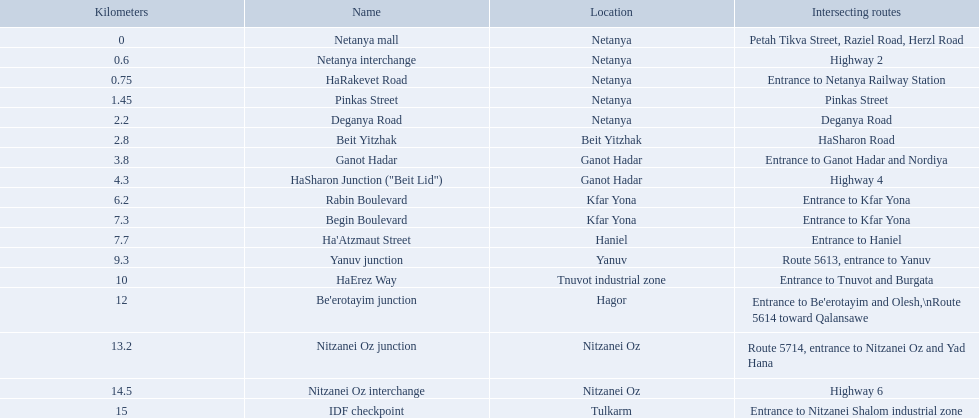What are all of the different portions? Netanya mall, Netanya interchange, HaRakevet Road, Pinkas Street, Deganya Road, Beit Yitzhak, Ganot Hadar, HaSharon Junction ("Beit Lid"), Rabin Boulevard, Begin Boulevard, Ha'Atzmaut Street, Yanuv junction, HaErez Way, Be'erotayim junction, Nitzanei Oz junction, Nitzanei Oz interchange, IDF checkpoint. What is the intersecting route for rabin boulevard? Entrance to Kfar Yona. What portion also has an intersecting route of entrance to kfar yona? Begin Boulevard. What is the converging route of rabin boulevard? Entrance to Kfar Yona. Which segment has this converging route? Begin Boulevard. What are all the designations? Netanya mall, Netanya interchange, HaRakevet Road, Pinkas Street, Deganya Road, Beit Yitzhak, Ganot Hadar, HaSharon Junction ("Beit Lid"), Rabin Boulevard, Begin Boulevard, Ha'Atzmaut Street, Yanuv junction, HaErez Way, Be'erotayim junction, Nitzanei Oz junction, Nitzanei Oz interchange, IDF checkpoint. Where do they meet? Petah Tikva Street, Raziel Road, Herzl Road, Highway 2, Entrance to Netanya Railway Station, Pinkas Street, Deganya Road, HaSharon Road, Entrance to Ganot Hadar and Nordiya, Highway 4, Entrance to Kfar Yona, Entrance to Kfar Yona, Entrance to Haniel, Route 5613, entrance to Yanuv, Entrance to Tnuvot and Burgata, Entrance to Be'erotayim and Olesh,\nRoute 5614 toward Qalansawe, Route 5714, entrance to Nitzanei Oz and Yad Hana, Highway 6, Entrance to Nitzanei Shalom industrial zone. And which one intersects with rabin boulevard? Begin Boulevard. What are the distinct sections? Netanya mall, Netanya interchange, HaRakevet Road, Pinkas Street, Deganya Road, Beit Yitzhak, Ganot Hadar, HaSharon Junction ("Beit Lid"), Rabin Boulevard, Begin Boulevard, Ha'Atzmaut Street, Yanuv junction, HaErez Way, Be'erotayim junction, Nitzanei Oz junction, Nitzanei Oz interchange, IDF checkpoint. What is the converging route on rabin boulevard? Entrance to Kfar Yona. What section also features a crossing path for access to kfar yona? Begin Boulevard. What are the separate parts? Netanya mall, Netanya interchange, HaRakevet Road, Pinkas Street, Deganya Road, Beit Yitzhak, Ganot Hadar, HaSharon Junction ("Beit Lid"), Rabin Boulevard, Begin Boulevard, Ha'Atzmaut Street, Yanuv junction, HaErez Way, Be'erotayim junction, Nitzanei Oz junction, Nitzanei Oz interchange, IDF checkpoint. What is the junction point for rabin boulevard? Entrance to Kfar Yona. Which part also contains an intersection for the entrance to kfar yona? Begin Boulevard. What are the various titles? Netanya mall, Netanya interchange, HaRakevet Road, Pinkas Street, Deganya Road, Beit Yitzhak, Ganot Hadar, HaSharon Junction ("Beit Lid"), Rabin Boulevard, Begin Boulevard, Ha'Atzmaut Street, Yanuv junction, HaErez Way, Be'erotayim junction, Nitzanei Oz junction, Nitzanei Oz interchange, IDF checkpoint. Where do they coincide? Petah Tikva Street, Raziel Road, Herzl Road, Highway 2, Entrance to Netanya Railway Station, Pinkas Street, Deganya Road, HaSharon Road, Entrance to Ganot Hadar and Nordiya, Highway 4, Entrance to Kfar Yona, Entrance to Kfar Yona, Entrance to Haniel, Route 5613, entrance to Yanuv, Entrance to Tnuvot and Burgata, Entrance to Be'erotayim and Olesh,\nRoute 5614 toward Qalansawe, Route 5714, entrance to Nitzanei Oz and Yad Hana, Highway 6, Entrance to Nitzanei Shalom industrial zone. And which one has a common point with rabin boulevard? Begin Boulevard. 